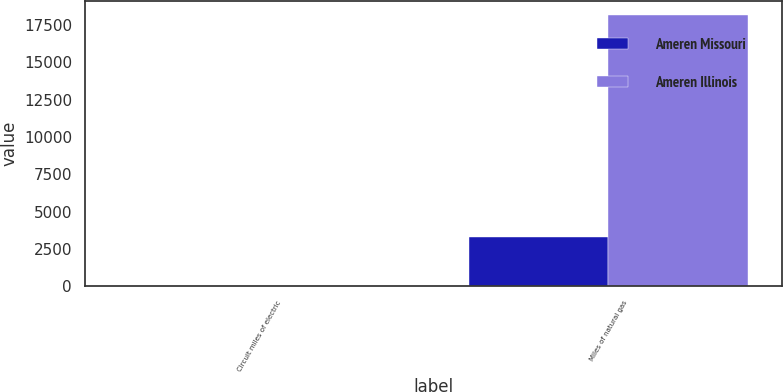Convert chart to OTSL. <chart><loc_0><loc_0><loc_500><loc_500><stacked_bar_chart><ecel><fcel>Circuit miles of electric<fcel>Miles of natural gas<nl><fcel>Ameren Missouri<fcel>23<fcel>3297<nl><fcel>Ameren Illinois<fcel>15<fcel>18190<nl></chart> 